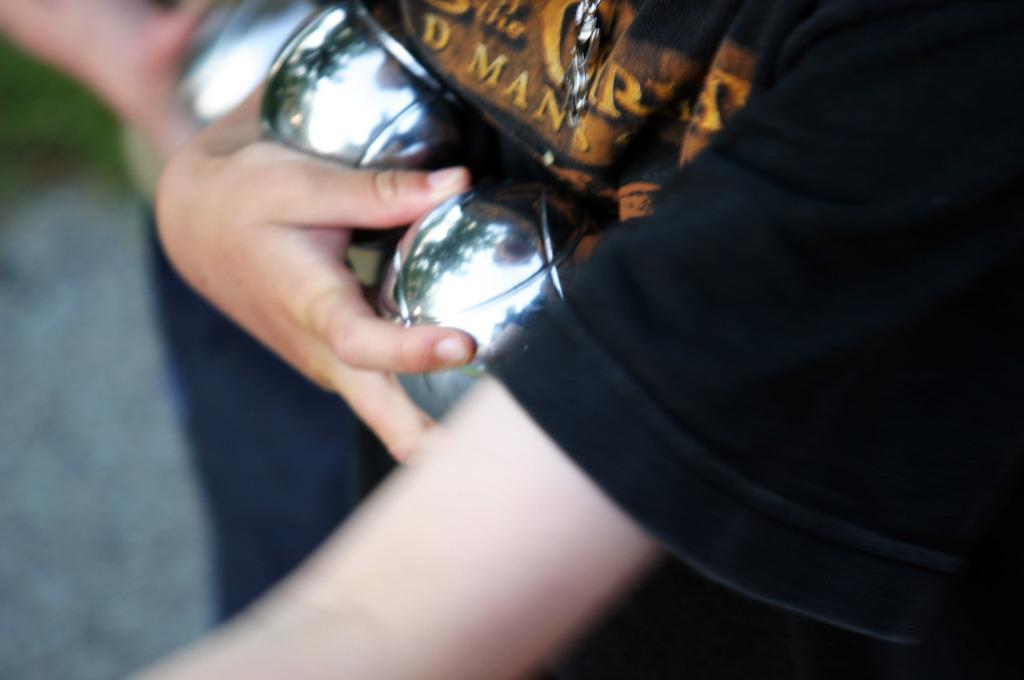How many people are in the image? There are two persons in the image. What are the persons holding in their hands? The persons are holding silver-colored things in their hands. Can you describe the quality of the image? The image is a bit blurry. What type of coat is the person wearing in the image? There is no coat visible in the image; the persons are holding silver-colored things in their hands. 